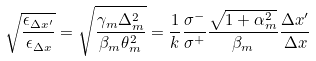<formula> <loc_0><loc_0><loc_500><loc_500>\sqrt { \frac { \epsilon _ { \Delta x ^ { \prime } } } { \epsilon _ { \Delta x } } } = \sqrt { \frac { \gamma _ { m } \Delta _ { m } ^ { 2 } } { \beta _ { m } \theta _ { m } ^ { 2 } } } = \frac { 1 } { k } \frac { \sigma ^ { - } } { \sigma ^ { + } } \frac { \sqrt { 1 + \alpha _ { m } ^ { 2 } } } { \beta _ { m } } \frac { \Delta x ^ { \prime } } { \Delta x }</formula> 